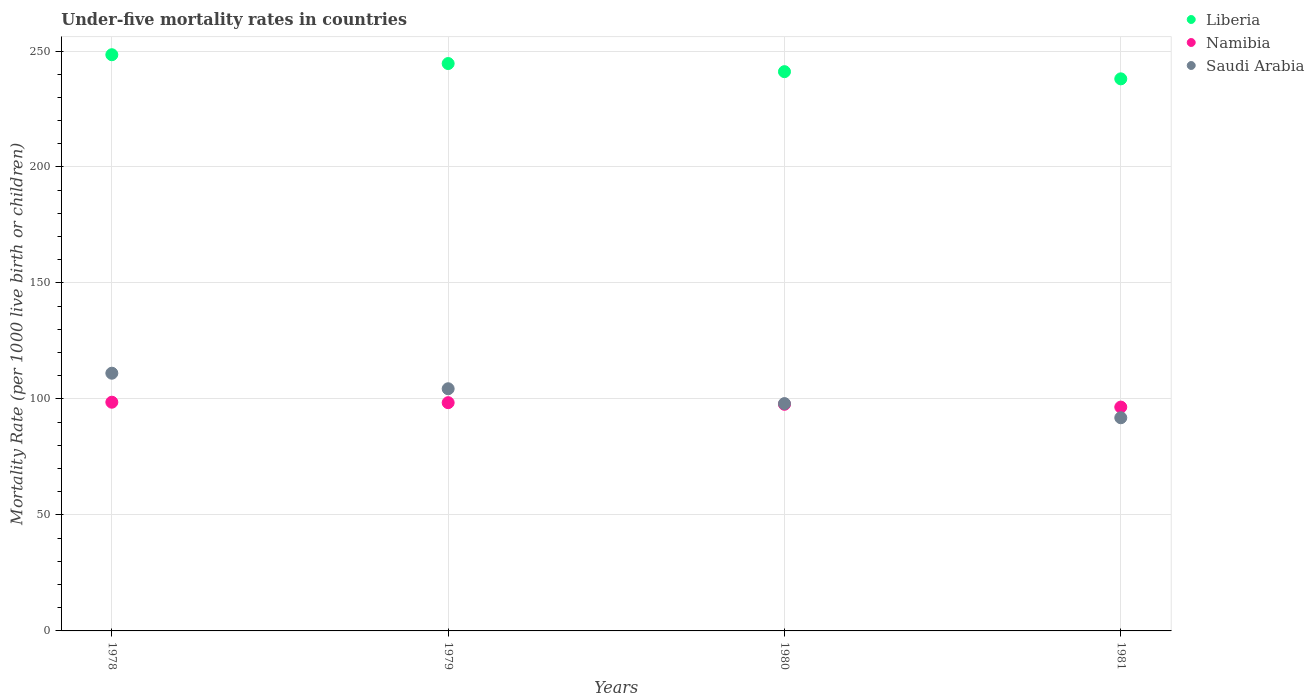Is the number of dotlines equal to the number of legend labels?
Provide a succinct answer. Yes. What is the under-five mortality rate in Liberia in 1980?
Keep it short and to the point. 241.1. Across all years, what is the maximum under-five mortality rate in Namibia?
Your answer should be very brief. 98.6. Across all years, what is the minimum under-five mortality rate in Saudi Arabia?
Offer a terse response. 91.9. In which year was the under-five mortality rate in Saudi Arabia maximum?
Your answer should be compact. 1978. In which year was the under-five mortality rate in Namibia minimum?
Offer a terse response. 1981. What is the total under-five mortality rate in Saudi Arabia in the graph?
Ensure brevity in your answer.  405.4. What is the difference between the under-five mortality rate in Namibia in 1978 and that in 1981?
Provide a short and direct response. 2.1. What is the difference between the under-five mortality rate in Liberia in 1979 and the under-five mortality rate in Namibia in 1978?
Your response must be concise. 146. What is the average under-five mortality rate in Liberia per year?
Provide a succinct answer. 243.03. In the year 1981, what is the difference between the under-five mortality rate in Liberia and under-five mortality rate in Namibia?
Provide a short and direct response. 141.5. What is the ratio of the under-five mortality rate in Namibia in 1979 to that in 1981?
Provide a succinct answer. 1.02. Is the difference between the under-five mortality rate in Liberia in 1978 and 1981 greater than the difference between the under-five mortality rate in Namibia in 1978 and 1981?
Offer a terse response. Yes. What is the difference between the highest and the second highest under-five mortality rate in Liberia?
Provide a succinct answer. 3.8. What is the difference between the highest and the lowest under-five mortality rate in Liberia?
Keep it short and to the point. 10.4. In how many years, is the under-five mortality rate in Saudi Arabia greater than the average under-five mortality rate in Saudi Arabia taken over all years?
Give a very brief answer. 2. Is it the case that in every year, the sum of the under-five mortality rate in Namibia and under-five mortality rate in Saudi Arabia  is greater than the under-five mortality rate in Liberia?
Your answer should be very brief. No. Is the under-five mortality rate in Liberia strictly less than the under-five mortality rate in Namibia over the years?
Make the answer very short. No. How many years are there in the graph?
Your answer should be compact. 4. Does the graph contain any zero values?
Provide a succinct answer. No. How many legend labels are there?
Your answer should be compact. 3. How are the legend labels stacked?
Your response must be concise. Vertical. What is the title of the graph?
Offer a very short reply. Under-five mortality rates in countries. What is the label or title of the X-axis?
Provide a short and direct response. Years. What is the label or title of the Y-axis?
Give a very brief answer. Mortality Rate (per 1000 live birth or children). What is the Mortality Rate (per 1000 live birth or children) of Liberia in 1978?
Your answer should be compact. 248.4. What is the Mortality Rate (per 1000 live birth or children) of Namibia in 1978?
Provide a succinct answer. 98.6. What is the Mortality Rate (per 1000 live birth or children) of Saudi Arabia in 1978?
Provide a short and direct response. 111.1. What is the Mortality Rate (per 1000 live birth or children) in Liberia in 1979?
Your answer should be compact. 244.6. What is the Mortality Rate (per 1000 live birth or children) in Namibia in 1979?
Keep it short and to the point. 98.4. What is the Mortality Rate (per 1000 live birth or children) in Saudi Arabia in 1979?
Offer a very short reply. 104.4. What is the Mortality Rate (per 1000 live birth or children) in Liberia in 1980?
Provide a short and direct response. 241.1. What is the Mortality Rate (per 1000 live birth or children) in Namibia in 1980?
Provide a succinct answer. 97.7. What is the Mortality Rate (per 1000 live birth or children) of Liberia in 1981?
Ensure brevity in your answer.  238. What is the Mortality Rate (per 1000 live birth or children) of Namibia in 1981?
Ensure brevity in your answer.  96.5. What is the Mortality Rate (per 1000 live birth or children) of Saudi Arabia in 1981?
Provide a succinct answer. 91.9. Across all years, what is the maximum Mortality Rate (per 1000 live birth or children) in Liberia?
Make the answer very short. 248.4. Across all years, what is the maximum Mortality Rate (per 1000 live birth or children) in Namibia?
Your answer should be very brief. 98.6. Across all years, what is the maximum Mortality Rate (per 1000 live birth or children) of Saudi Arabia?
Provide a short and direct response. 111.1. Across all years, what is the minimum Mortality Rate (per 1000 live birth or children) of Liberia?
Offer a terse response. 238. Across all years, what is the minimum Mortality Rate (per 1000 live birth or children) in Namibia?
Ensure brevity in your answer.  96.5. Across all years, what is the minimum Mortality Rate (per 1000 live birth or children) in Saudi Arabia?
Keep it short and to the point. 91.9. What is the total Mortality Rate (per 1000 live birth or children) of Liberia in the graph?
Provide a succinct answer. 972.1. What is the total Mortality Rate (per 1000 live birth or children) of Namibia in the graph?
Offer a very short reply. 391.2. What is the total Mortality Rate (per 1000 live birth or children) in Saudi Arabia in the graph?
Give a very brief answer. 405.4. What is the difference between the Mortality Rate (per 1000 live birth or children) of Liberia in 1978 and that in 1980?
Provide a succinct answer. 7.3. What is the difference between the Mortality Rate (per 1000 live birth or children) in Namibia in 1978 and that in 1980?
Give a very brief answer. 0.9. What is the difference between the Mortality Rate (per 1000 live birth or children) of Saudi Arabia in 1978 and that in 1980?
Offer a terse response. 13.1. What is the difference between the Mortality Rate (per 1000 live birth or children) of Namibia in 1978 and that in 1981?
Provide a succinct answer. 2.1. What is the difference between the Mortality Rate (per 1000 live birth or children) of Saudi Arabia in 1978 and that in 1981?
Keep it short and to the point. 19.2. What is the difference between the Mortality Rate (per 1000 live birth or children) in Liberia in 1979 and that in 1980?
Provide a succinct answer. 3.5. What is the difference between the Mortality Rate (per 1000 live birth or children) of Saudi Arabia in 1980 and that in 1981?
Ensure brevity in your answer.  6.1. What is the difference between the Mortality Rate (per 1000 live birth or children) in Liberia in 1978 and the Mortality Rate (per 1000 live birth or children) in Namibia in 1979?
Make the answer very short. 150. What is the difference between the Mortality Rate (per 1000 live birth or children) in Liberia in 1978 and the Mortality Rate (per 1000 live birth or children) in Saudi Arabia in 1979?
Ensure brevity in your answer.  144. What is the difference between the Mortality Rate (per 1000 live birth or children) in Liberia in 1978 and the Mortality Rate (per 1000 live birth or children) in Namibia in 1980?
Ensure brevity in your answer.  150.7. What is the difference between the Mortality Rate (per 1000 live birth or children) in Liberia in 1978 and the Mortality Rate (per 1000 live birth or children) in Saudi Arabia in 1980?
Keep it short and to the point. 150.4. What is the difference between the Mortality Rate (per 1000 live birth or children) of Liberia in 1978 and the Mortality Rate (per 1000 live birth or children) of Namibia in 1981?
Keep it short and to the point. 151.9. What is the difference between the Mortality Rate (per 1000 live birth or children) of Liberia in 1978 and the Mortality Rate (per 1000 live birth or children) of Saudi Arabia in 1981?
Make the answer very short. 156.5. What is the difference between the Mortality Rate (per 1000 live birth or children) in Liberia in 1979 and the Mortality Rate (per 1000 live birth or children) in Namibia in 1980?
Make the answer very short. 146.9. What is the difference between the Mortality Rate (per 1000 live birth or children) of Liberia in 1979 and the Mortality Rate (per 1000 live birth or children) of Saudi Arabia in 1980?
Give a very brief answer. 146.6. What is the difference between the Mortality Rate (per 1000 live birth or children) in Liberia in 1979 and the Mortality Rate (per 1000 live birth or children) in Namibia in 1981?
Your answer should be very brief. 148.1. What is the difference between the Mortality Rate (per 1000 live birth or children) of Liberia in 1979 and the Mortality Rate (per 1000 live birth or children) of Saudi Arabia in 1981?
Offer a terse response. 152.7. What is the difference between the Mortality Rate (per 1000 live birth or children) of Namibia in 1979 and the Mortality Rate (per 1000 live birth or children) of Saudi Arabia in 1981?
Give a very brief answer. 6.5. What is the difference between the Mortality Rate (per 1000 live birth or children) of Liberia in 1980 and the Mortality Rate (per 1000 live birth or children) of Namibia in 1981?
Offer a very short reply. 144.6. What is the difference between the Mortality Rate (per 1000 live birth or children) of Liberia in 1980 and the Mortality Rate (per 1000 live birth or children) of Saudi Arabia in 1981?
Your answer should be very brief. 149.2. What is the average Mortality Rate (per 1000 live birth or children) of Liberia per year?
Keep it short and to the point. 243.03. What is the average Mortality Rate (per 1000 live birth or children) in Namibia per year?
Give a very brief answer. 97.8. What is the average Mortality Rate (per 1000 live birth or children) in Saudi Arabia per year?
Offer a terse response. 101.35. In the year 1978, what is the difference between the Mortality Rate (per 1000 live birth or children) in Liberia and Mortality Rate (per 1000 live birth or children) in Namibia?
Give a very brief answer. 149.8. In the year 1978, what is the difference between the Mortality Rate (per 1000 live birth or children) in Liberia and Mortality Rate (per 1000 live birth or children) in Saudi Arabia?
Your answer should be very brief. 137.3. In the year 1978, what is the difference between the Mortality Rate (per 1000 live birth or children) in Namibia and Mortality Rate (per 1000 live birth or children) in Saudi Arabia?
Offer a terse response. -12.5. In the year 1979, what is the difference between the Mortality Rate (per 1000 live birth or children) of Liberia and Mortality Rate (per 1000 live birth or children) of Namibia?
Provide a short and direct response. 146.2. In the year 1979, what is the difference between the Mortality Rate (per 1000 live birth or children) of Liberia and Mortality Rate (per 1000 live birth or children) of Saudi Arabia?
Your response must be concise. 140.2. In the year 1979, what is the difference between the Mortality Rate (per 1000 live birth or children) of Namibia and Mortality Rate (per 1000 live birth or children) of Saudi Arabia?
Ensure brevity in your answer.  -6. In the year 1980, what is the difference between the Mortality Rate (per 1000 live birth or children) in Liberia and Mortality Rate (per 1000 live birth or children) in Namibia?
Ensure brevity in your answer.  143.4. In the year 1980, what is the difference between the Mortality Rate (per 1000 live birth or children) of Liberia and Mortality Rate (per 1000 live birth or children) of Saudi Arabia?
Keep it short and to the point. 143.1. In the year 1980, what is the difference between the Mortality Rate (per 1000 live birth or children) of Namibia and Mortality Rate (per 1000 live birth or children) of Saudi Arabia?
Your answer should be very brief. -0.3. In the year 1981, what is the difference between the Mortality Rate (per 1000 live birth or children) of Liberia and Mortality Rate (per 1000 live birth or children) of Namibia?
Keep it short and to the point. 141.5. In the year 1981, what is the difference between the Mortality Rate (per 1000 live birth or children) of Liberia and Mortality Rate (per 1000 live birth or children) of Saudi Arabia?
Offer a very short reply. 146.1. In the year 1981, what is the difference between the Mortality Rate (per 1000 live birth or children) of Namibia and Mortality Rate (per 1000 live birth or children) of Saudi Arabia?
Your answer should be compact. 4.6. What is the ratio of the Mortality Rate (per 1000 live birth or children) in Liberia in 1978 to that in 1979?
Provide a short and direct response. 1.02. What is the ratio of the Mortality Rate (per 1000 live birth or children) in Namibia in 1978 to that in 1979?
Make the answer very short. 1. What is the ratio of the Mortality Rate (per 1000 live birth or children) of Saudi Arabia in 1978 to that in 1979?
Provide a short and direct response. 1.06. What is the ratio of the Mortality Rate (per 1000 live birth or children) in Liberia in 1978 to that in 1980?
Make the answer very short. 1.03. What is the ratio of the Mortality Rate (per 1000 live birth or children) of Namibia in 1978 to that in 1980?
Make the answer very short. 1.01. What is the ratio of the Mortality Rate (per 1000 live birth or children) in Saudi Arabia in 1978 to that in 1980?
Offer a very short reply. 1.13. What is the ratio of the Mortality Rate (per 1000 live birth or children) of Liberia in 1978 to that in 1981?
Your answer should be very brief. 1.04. What is the ratio of the Mortality Rate (per 1000 live birth or children) of Namibia in 1978 to that in 1981?
Your answer should be compact. 1.02. What is the ratio of the Mortality Rate (per 1000 live birth or children) of Saudi Arabia in 1978 to that in 1981?
Make the answer very short. 1.21. What is the ratio of the Mortality Rate (per 1000 live birth or children) of Liberia in 1979 to that in 1980?
Your answer should be very brief. 1.01. What is the ratio of the Mortality Rate (per 1000 live birth or children) in Namibia in 1979 to that in 1980?
Give a very brief answer. 1.01. What is the ratio of the Mortality Rate (per 1000 live birth or children) in Saudi Arabia in 1979 to that in 1980?
Offer a terse response. 1.07. What is the ratio of the Mortality Rate (per 1000 live birth or children) in Liberia in 1979 to that in 1981?
Provide a succinct answer. 1.03. What is the ratio of the Mortality Rate (per 1000 live birth or children) in Namibia in 1979 to that in 1981?
Offer a terse response. 1.02. What is the ratio of the Mortality Rate (per 1000 live birth or children) in Saudi Arabia in 1979 to that in 1981?
Your answer should be compact. 1.14. What is the ratio of the Mortality Rate (per 1000 live birth or children) in Namibia in 1980 to that in 1981?
Keep it short and to the point. 1.01. What is the ratio of the Mortality Rate (per 1000 live birth or children) of Saudi Arabia in 1980 to that in 1981?
Provide a succinct answer. 1.07. What is the difference between the highest and the second highest Mortality Rate (per 1000 live birth or children) in Liberia?
Ensure brevity in your answer.  3.8. 